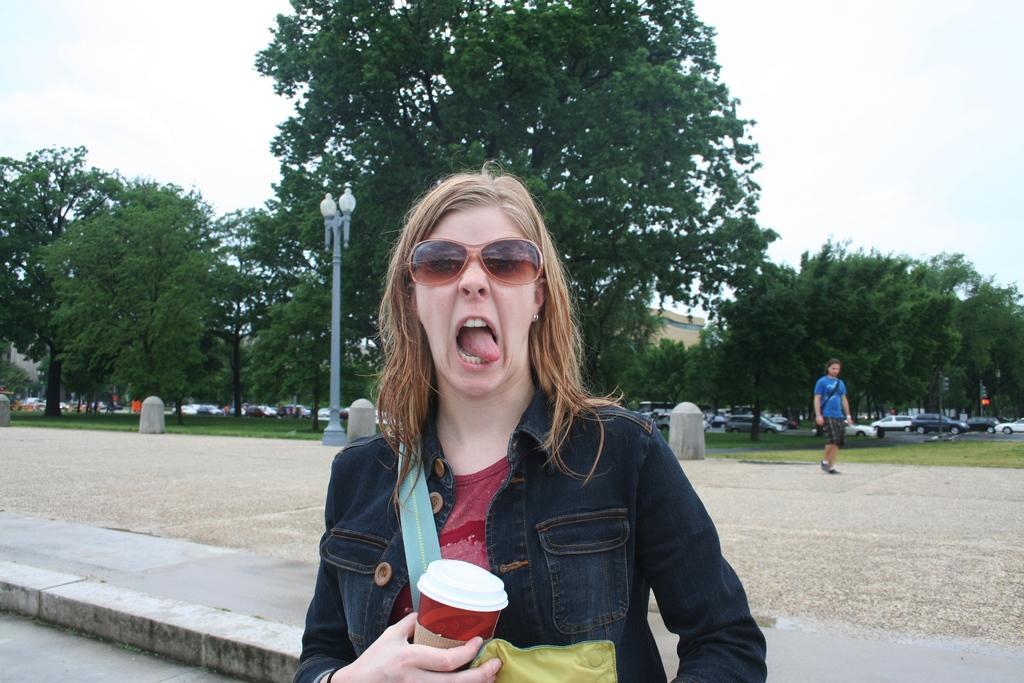How would you summarize this image in a sentence or two? This is an outside view. Here I can see a woman holding a glass in the hand, wearing a jacket, goggles and giving pose for the picture. In the background there are many trees, cars and a building. On the right side there is a person walking on the ground. On the left side there is a light pole. At the top of the image I can see the sky. 